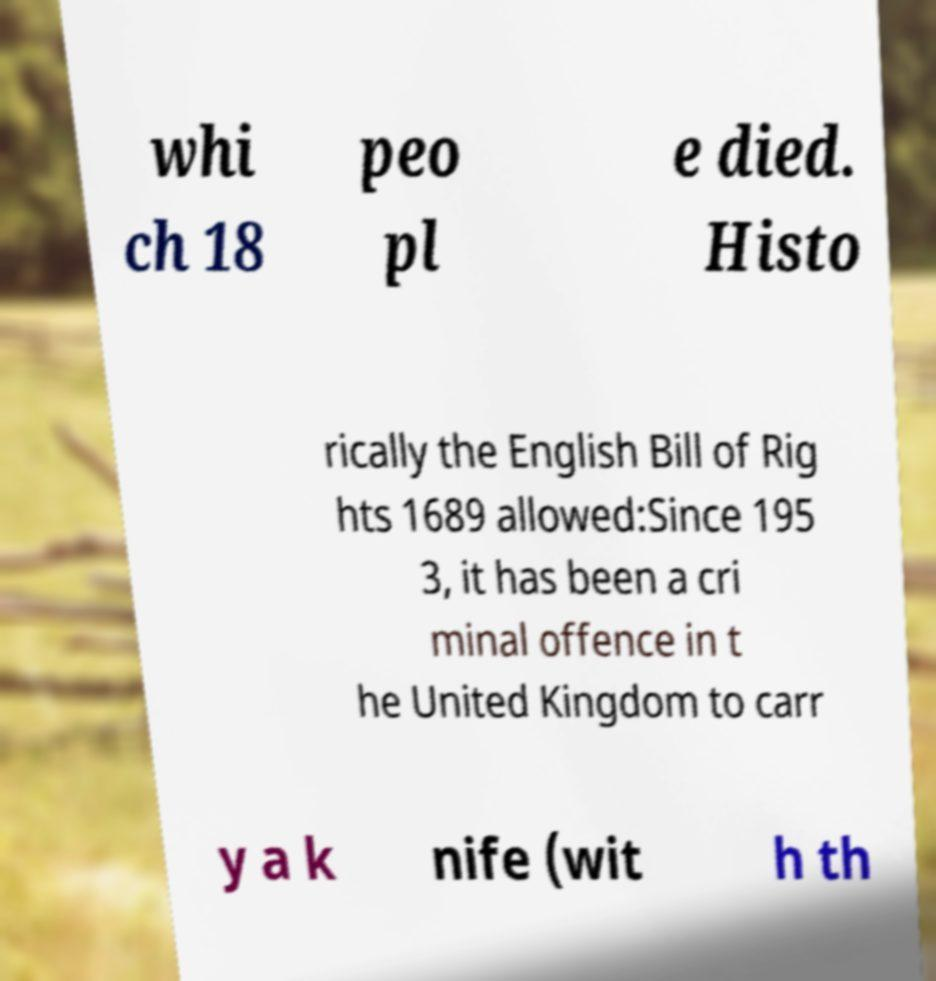What messages or text are displayed in this image? I need them in a readable, typed format. whi ch 18 peo pl e died. Histo rically the English Bill of Rig hts 1689 allowed:Since 195 3, it has been a cri minal offence in t he United Kingdom to carr y a k nife (wit h th 